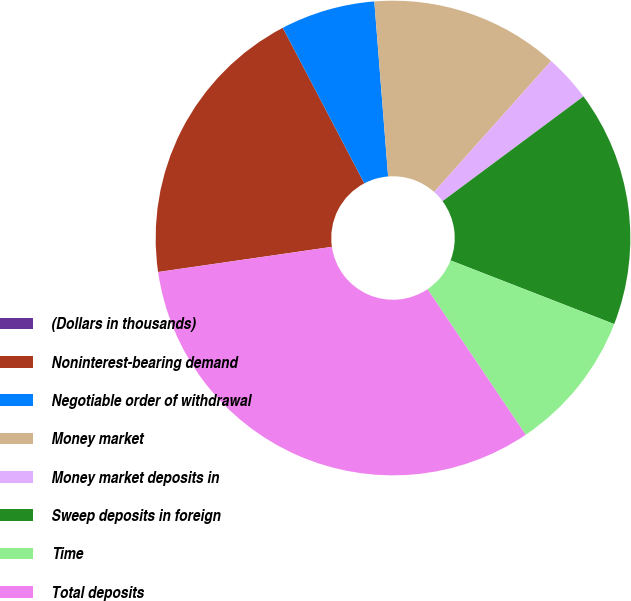<chart> <loc_0><loc_0><loc_500><loc_500><pie_chart><fcel>(Dollars in thousands)<fcel>Noninterest-bearing demand<fcel>Negotiable order of withdrawal<fcel>Money market<fcel>Money market deposits in<fcel>Sweep deposits in foreign<fcel>Time<fcel>Total deposits<nl><fcel>0.01%<fcel>19.6%<fcel>6.43%<fcel>12.86%<fcel>3.22%<fcel>16.08%<fcel>9.65%<fcel>32.15%<nl></chart> 